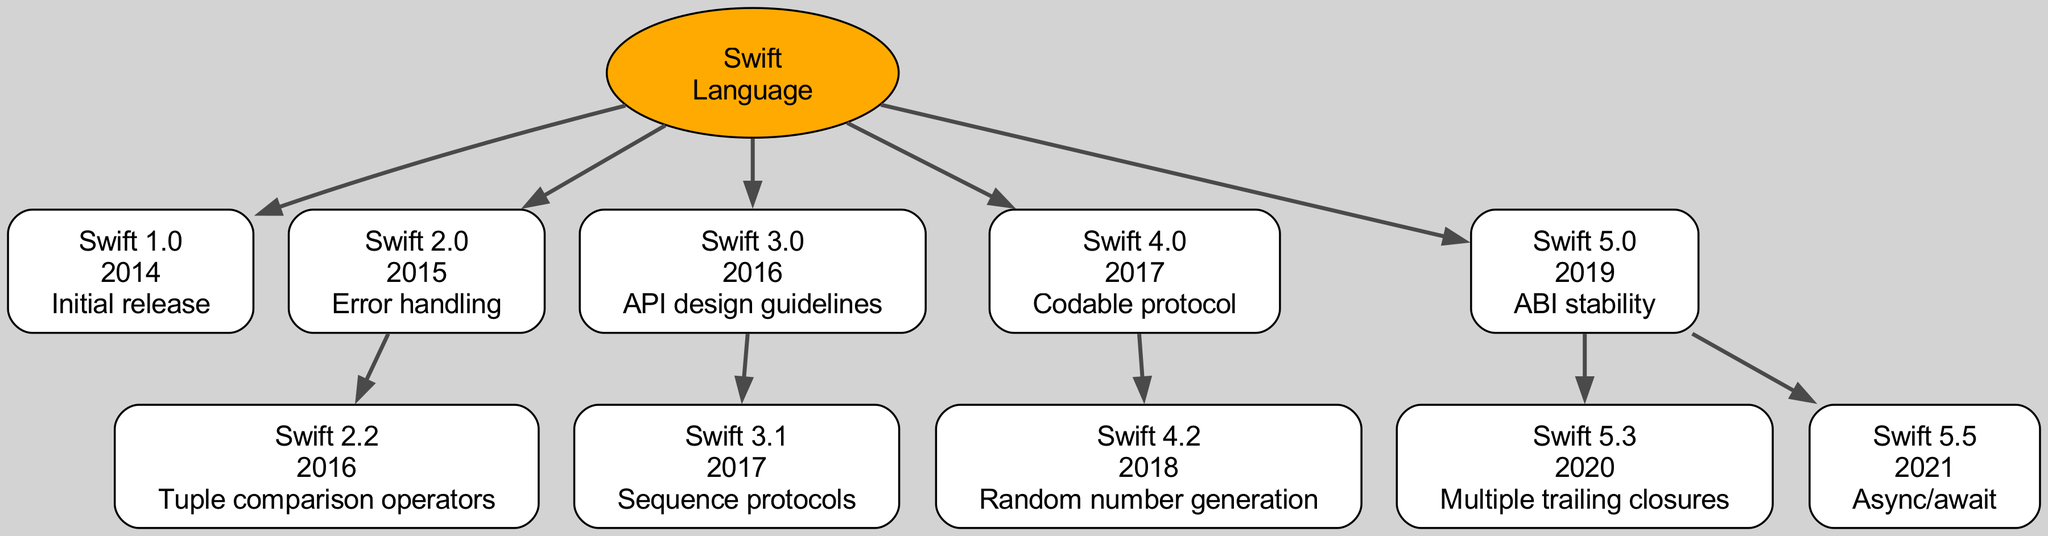What is the initial release version of Swift? The initial release version of Swift, as indicated in the diagram, is Swift 1.0. It is the first child of the root node "Swift" and is labeled with the year 2014 and the feature "Initial release."
Answer: Swift 1.0 How many major versions of Swift are shown in the diagram? The diagram contains five major versions of Swift from the root node to its immediate children. These versions are Swift 1.0, Swift 2.0, Swift 3.0, Swift 4.0, and Swift 5.0.
Answer: five Which version introduced async/await? The feature async/await was introduced in Swift 5.5, as shown in the diagram. It is a child node of Swift 5.0, which is an earlier version.
Answer: Swift 5.5 What year was Swift 4.2 released? Swift 4.2 was released in the year 2018, according to the diagram, where it is displayed as a child of Swift 4.0.
Answer: 2018 Which versions of Swift have at least one child version? The versions that have at least one child version are Swift 2.0, Swift 3.0, Swift 4.0, and Swift 5.0, as they all have additional versions listed under them in the diagram.
Answer: Swift 2.0, Swift 3.0, Swift 4.0, Swift 5.0 Which feature is associated with Swift 4.0? The feature associated with Swift 4.0 is the "Codable protocol" as noted in the diagram under its node details.
Answer: Codable protocol How does Swift 5.3 relate to Swift 5.0? Swift 5.3 is a child version of Swift 5.0, which indicates that it is a subsequent release building upon the Swift 5.0 foundation in the diagram's structure.
Answer: Child version What is the relationship between Swift 2.0 and Swift 2.2? Swift 2.2 is a child of Swift 2.0, indicating that it is a subsequent version developed following the Swift 2.0 release.
Answer: Parent-child relationship 